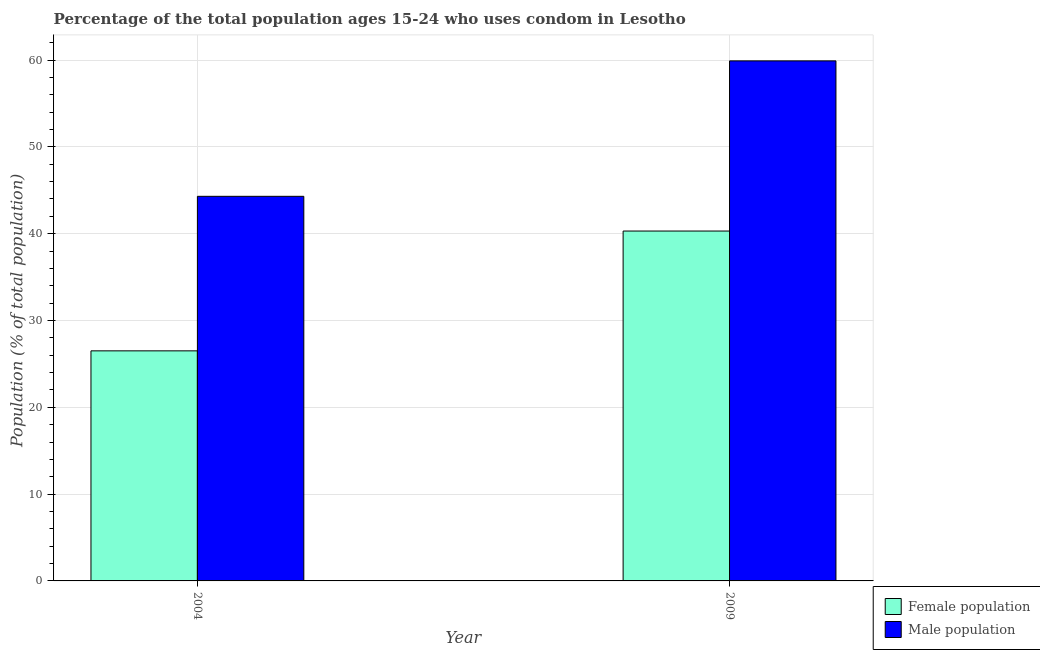How many groups of bars are there?
Make the answer very short. 2. Are the number of bars on each tick of the X-axis equal?
Offer a terse response. Yes. How many bars are there on the 1st tick from the left?
Provide a succinct answer. 2. How many bars are there on the 1st tick from the right?
Provide a succinct answer. 2. In how many cases, is the number of bars for a given year not equal to the number of legend labels?
Provide a short and direct response. 0. What is the female population in 2009?
Offer a terse response. 40.3. Across all years, what is the maximum male population?
Offer a very short reply. 59.9. In which year was the female population maximum?
Give a very brief answer. 2009. In which year was the male population minimum?
Keep it short and to the point. 2004. What is the total male population in the graph?
Ensure brevity in your answer.  104.2. What is the difference between the female population in 2004 and that in 2009?
Your answer should be very brief. -13.8. What is the difference between the female population in 2009 and the male population in 2004?
Provide a short and direct response. 13.8. What is the average female population per year?
Offer a terse response. 33.4. In how many years, is the female population greater than 52 %?
Ensure brevity in your answer.  0. What is the ratio of the female population in 2004 to that in 2009?
Provide a succinct answer. 0.66. In how many years, is the male population greater than the average male population taken over all years?
Offer a terse response. 1. What does the 2nd bar from the left in 2004 represents?
Your answer should be compact. Male population. What does the 1st bar from the right in 2009 represents?
Make the answer very short. Male population. How many bars are there?
Make the answer very short. 4. Does the graph contain grids?
Your answer should be very brief. Yes. Where does the legend appear in the graph?
Offer a terse response. Bottom right. How are the legend labels stacked?
Provide a short and direct response. Vertical. What is the title of the graph?
Your response must be concise. Percentage of the total population ages 15-24 who uses condom in Lesotho. What is the label or title of the Y-axis?
Give a very brief answer. Population (% of total population) . What is the Population (% of total population)  of Female population in 2004?
Your answer should be very brief. 26.5. What is the Population (% of total population)  in Male population in 2004?
Offer a very short reply. 44.3. What is the Population (% of total population)  of Female population in 2009?
Make the answer very short. 40.3. What is the Population (% of total population)  of Male population in 2009?
Offer a terse response. 59.9. Across all years, what is the maximum Population (% of total population)  of Female population?
Offer a very short reply. 40.3. Across all years, what is the maximum Population (% of total population)  of Male population?
Your response must be concise. 59.9. Across all years, what is the minimum Population (% of total population)  in Female population?
Your answer should be very brief. 26.5. Across all years, what is the minimum Population (% of total population)  of Male population?
Keep it short and to the point. 44.3. What is the total Population (% of total population)  in Female population in the graph?
Make the answer very short. 66.8. What is the total Population (% of total population)  in Male population in the graph?
Give a very brief answer. 104.2. What is the difference between the Population (% of total population)  of Female population in 2004 and that in 2009?
Provide a short and direct response. -13.8. What is the difference between the Population (% of total population)  in Male population in 2004 and that in 2009?
Offer a very short reply. -15.6. What is the difference between the Population (% of total population)  of Female population in 2004 and the Population (% of total population)  of Male population in 2009?
Your answer should be compact. -33.4. What is the average Population (% of total population)  of Female population per year?
Your answer should be very brief. 33.4. What is the average Population (% of total population)  in Male population per year?
Give a very brief answer. 52.1. In the year 2004, what is the difference between the Population (% of total population)  in Female population and Population (% of total population)  in Male population?
Your response must be concise. -17.8. In the year 2009, what is the difference between the Population (% of total population)  of Female population and Population (% of total population)  of Male population?
Keep it short and to the point. -19.6. What is the ratio of the Population (% of total population)  in Female population in 2004 to that in 2009?
Offer a very short reply. 0.66. What is the ratio of the Population (% of total population)  of Male population in 2004 to that in 2009?
Your response must be concise. 0.74. What is the difference between the highest and the second highest Population (% of total population)  of Female population?
Offer a terse response. 13.8. 